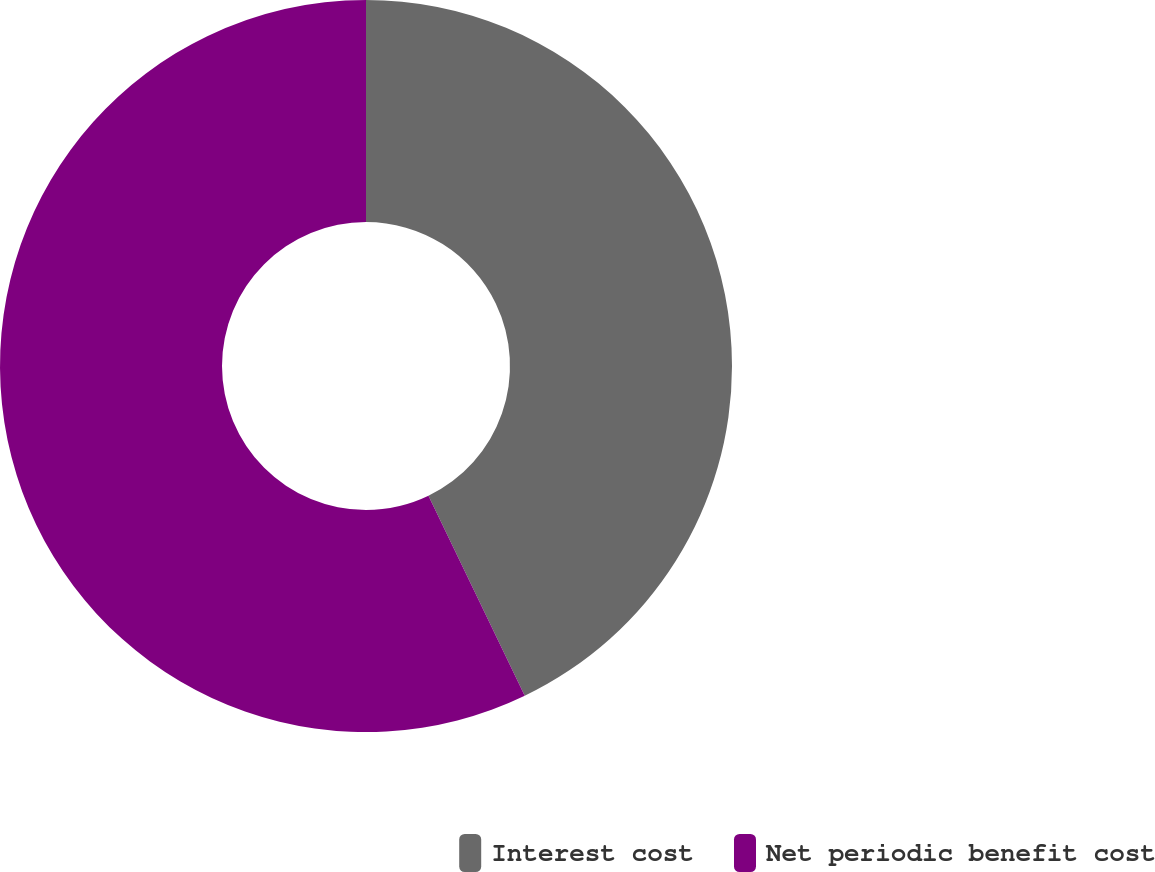Convert chart to OTSL. <chart><loc_0><loc_0><loc_500><loc_500><pie_chart><fcel>Interest cost<fcel>Net periodic benefit cost<nl><fcel>42.86%<fcel>57.14%<nl></chart> 